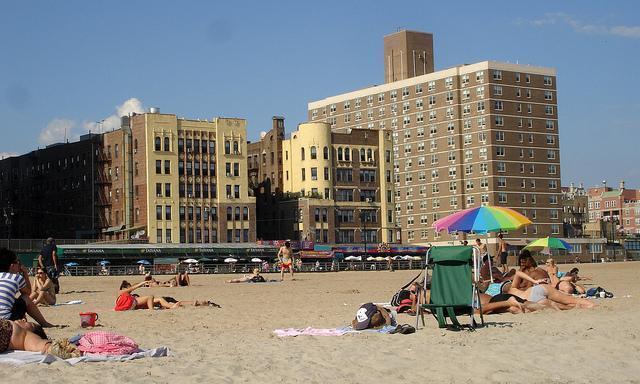Where is someone who might easily overheat safest here?
Answer the question by selecting the correct answer among the 4 following choices.
Options: On chair, under umbrella, in sand, water's edge. Under umbrella. 